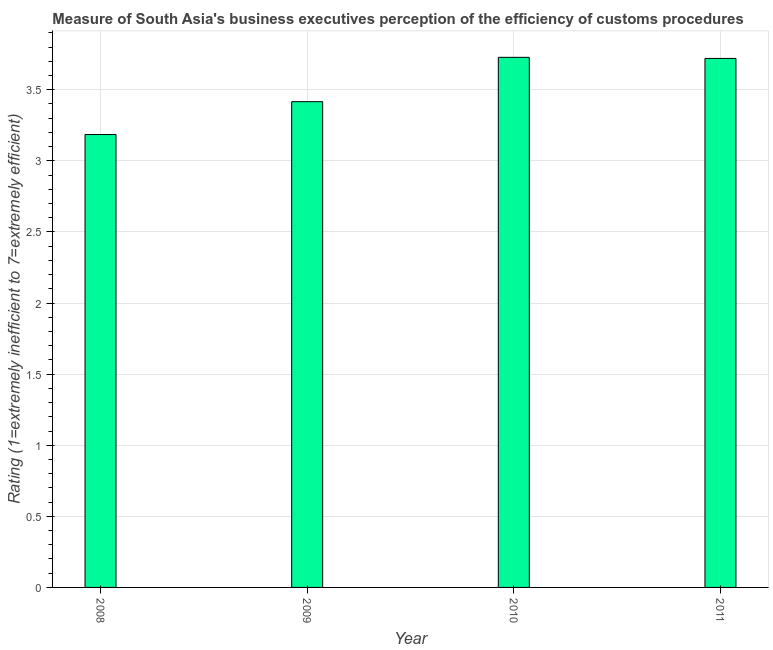Does the graph contain any zero values?
Offer a very short reply. No. Does the graph contain grids?
Your answer should be very brief. Yes. What is the title of the graph?
Your answer should be compact. Measure of South Asia's business executives perception of the efficiency of customs procedures. What is the label or title of the Y-axis?
Provide a short and direct response. Rating (1=extremely inefficient to 7=extremely efficient). What is the rating measuring burden of customs procedure in 2010?
Ensure brevity in your answer.  3.73. Across all years, what is the maximum rating measuring burden of customs procedure?
Provide a short and direct response. 3.73. Across all years, what is the minimum rating measuring burden of customs procedure?
Your answer should be compact. 3.18. What is the sum of the rating measuring burden of customs procedure?
Your response must be concise. 14.05. What is the difference between the rating measuring burden of customs procedure in 2008 and 2009?
Your response must be concise. -0.23. What is the average rating measuring burden of customs procedure per year?
Keep it short and to the point. 3.51. What is the median rating measuring burden of customs procedure?
Your answer should be compact. 3.57. What is the ratio of the rating measuring burden of customs procedure in 2009 to that in 2010?
Your answer should be very brief. 0.92. What is the difference between the highest and the second highest rating measuring burden of customs procedure?
Your answer should be compact. 0.01. What is the difference between the highest and the lowest rating measuring burden of customs procedure?
Offer a terse response. 0.54. How many bars are there?
Make the answer very short. 4. Are all the bars in the graph horizontal?
Your answer should be very brief. No. How many years are there in the graph?
Give a very brief answer. 4. What is the difference between two consecutive major ticks on the Y-axis?
Your response must be concise. 0.5. Are the values on the major ticks of Y-axis written in scientific E-notation?
Give a very brief answer. No. What is the Rating (1=extremely inefficient to 7=extremely efficient) in 2008?
Offer a terse response. 3.18. What is the Rating (1=extremely inefficient to 7=extremely efficient) in 2009?
Your answer should be very brief. 3.42. What is the Rating (1=extremely inefficient to 7=extremely efficient) of 2010?
Your response must be concise. 3.73. What is the Rating (1=extremely inefficient to 7=extremely efficient) in 2011?
Give a very brief answer. 3.72. What is the difference between the Rating (1=extremely inefficient to 7=extremely efficient) in 2008 and 2009?
Keep it short and to the point. -0.23. What is the difference between the Rating (1=extremely inefficient to 7=extremely efficient) in 2008 and 2010?
Your answer should be compact. -0.54. What is the difference between the Rating (1=extremely inefficient to 7=extremely efficient) in 2008 and 2011?
Your response must be concise. -0.54. What is the difference between the Rating (1=extremely inefficient to 7=extremely efficient) in 2009 and 2010?
Provide a short and direct response. -0.31. What is the difference between the Rating (1=extremely inefficient to 7=extremely efficient) in 2009 and 2011?
Your answer should be compact. -0.3. What is the difference between the Rating (1=extremely inefficient to 7=extremely efficient) in 2010 and 2011?
Give a very brief answer. 0.01. What is the ratio of the Rating (1=extremely inefficient to 7=extremely efficient) in 2008 to that in 2009?
Your answer should be compact. 0.93. What is the ratio of the Rating (1=extremely inefficient to 7=extremely efficient) in 2008 to that in 2010?
Offer a terse response. 0.85. What is the ratio of the Rating (1=extremely inefficient to 7=extremely efficient) in 2008 to that in 2011?
Provide a short and direct response. 0.86. What is the ratio of the Rating (1=extremely inefficient to 7=extremely efficient) in 2009 to that in 2010?
Provide a short and direct response. 0.92. What is the ratio of the Rating (1=extremely inefficient to 7=extremely efficient) in 2009 to that in 2011?
Keep it short and to the point. 0.92. 